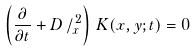Convert formula to latex. <formula><loc_0><loc_0><loc_500><loc_500>\left ( \frac { \partial } { \partial t } + D \, / _ { x } ^ { \, 2 } \right ) \, K ( x , y ; t ) = 0</formula> 